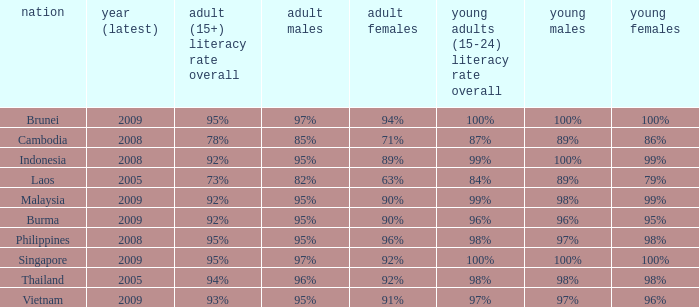Which country has a Youth (15-24) Literacy Rate Total of 100% and has an Adult Women Literacy rate of 92%? Singapore. 